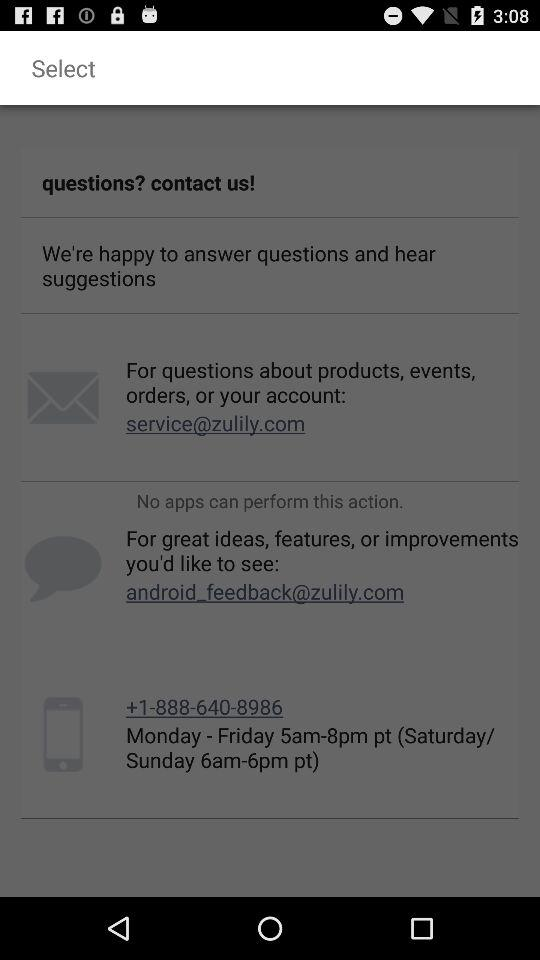At what email address can I inquire about the product? You can inquire about the product at service@zulily.com. 